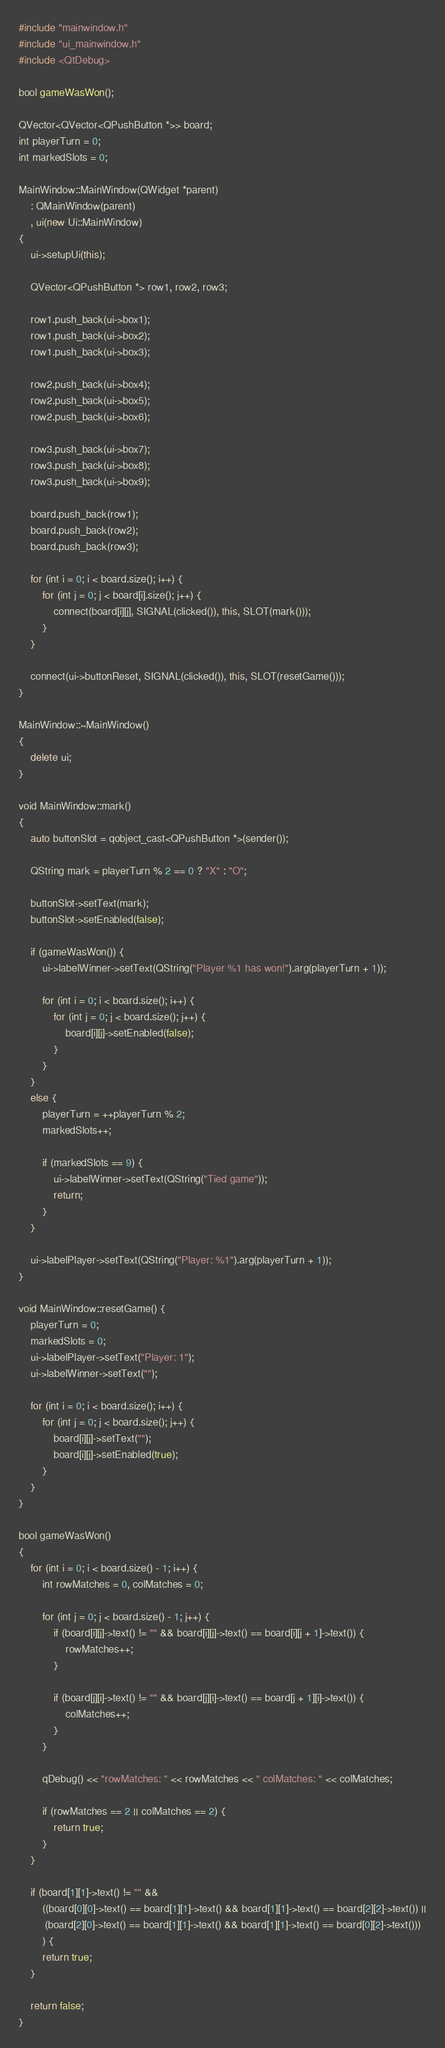Convert code to text. <code><loc_0><loc_0><loc_500><loc_500><_C++_>#include "mainwindow.h"
#include "ui_mainwindow.h"
#include <QtDebug>

bool gameWasWon();

QVector<QVector<QPushButton *>> board;
int playerTurn = 0;
int markedSlots = 0;

MainWindow::MainWindow(QWidget *parent)
    : QMainWindow(parent)
    , ui(new Ui::MainWindow)
{
    ui->setupUi(this);

    QVector<QPushButton *> row1, row2, row3;

    row1.push_back(ui->box1);
    row1.push_back(ui->box2);
    row1.push_back(ui->box3);

    row2.push_back(ui->box4);
    row2.push_back(ui->box5);
    row2.push_back(ui->box6);

    row3.push_back(ui->box7);
    row3.push_back(ui->box8);
    row3.push_back(ui->box9);

    board.push_back(row1);
    board.push_back(row2);
    board.push_back(row3);

    for (int i = 0; i < board.size(); i++) {
        for (int j = 0; j < board[i].size(); j++) {
            connect(board[i][j], SIGNAL(clicked()), this, SLOT(mark()));
        }
    }

    connect(ui->buttonReset, SIGNAL(clicked()), this, SLOT(resetGame()));
}

MainWindow::~MainWindow()
{
    delete ui;
}

void MainWindow::mark()
{
    auto buttonSlot = qobject_cast<QPushButton *>(sender());

    QString mark = playerTurn % 2 == 0 ? "X" : "O";

    buttonSlot->setText(mark);
    buttonSlot->setEnabled(false);

    if (gameWasWon()) {
        ui->labelWinner->setText(QString("Player %1 has won!").arg(playerTurn + 1));

        for (int i = 0; i < board.size(); i++) {
            for (int j = 0; j < board.size(); j++) {
                board[i][j]->setEnabled(false);
            }
        }
    }
    else {
        playerTurn = ++playerTurn % 2;
        markedSlots++;

        if (markedSlots == 9) {
            ui->labelWinner->setText(QString("Tied game"));
            return;
        }
    }

    ui->labelPlayer->setText(QString("Player: %1").arg(playerTurn + 1));
}

void MainWindow::resetGame() {
    playerTurn = 0;
    markedSlots = 0;
    ui->labelPlayer->setText("Player: 1");
    ui->labelWinner->setText("");

    for (int i = 0; i < board.size(); i++) {
        for (int j = 0; j < board.size(); j++) {
            board[i][j]->setText("");
            board[i][j]->setEnabled(true);
        }
    }
}

bool gameWasWon()
{
    for (int i = 0; i < board.size() - 1; i++) {
        int rowMatches = 0, colMatches = 0;

        for (int j = 0; j < board.size() - 1; j++) {
            if (board[i][j]->text() != "" && board[i][j]->text() == board[i][j + 1]->text()) {
                rowMatches++;
            }

            if (board[j][i]->text() != "" && board[j][i]->text() == board[j + 1][i]->text()) {
                colMatches++;
            }
        }

        qDebug() << "rowMatches: " << rowMatches << " colMatches: " << colMatches;

        if (rowMatches == 2 || colMatches == 2) {
            return true;
        }
    }

    if (board[1][1]->text() != "" &&
        ((board[0][0]->text() == board[1][1]->text() && board[1][1]->text() == board[2][2]->text()) ||
         (board[2][0]->text() == board[1][1]->text() && board[1][1]->text() == board[0][2]->text()))
        ) {
        return true;
    }

    return false;
}
</code> 